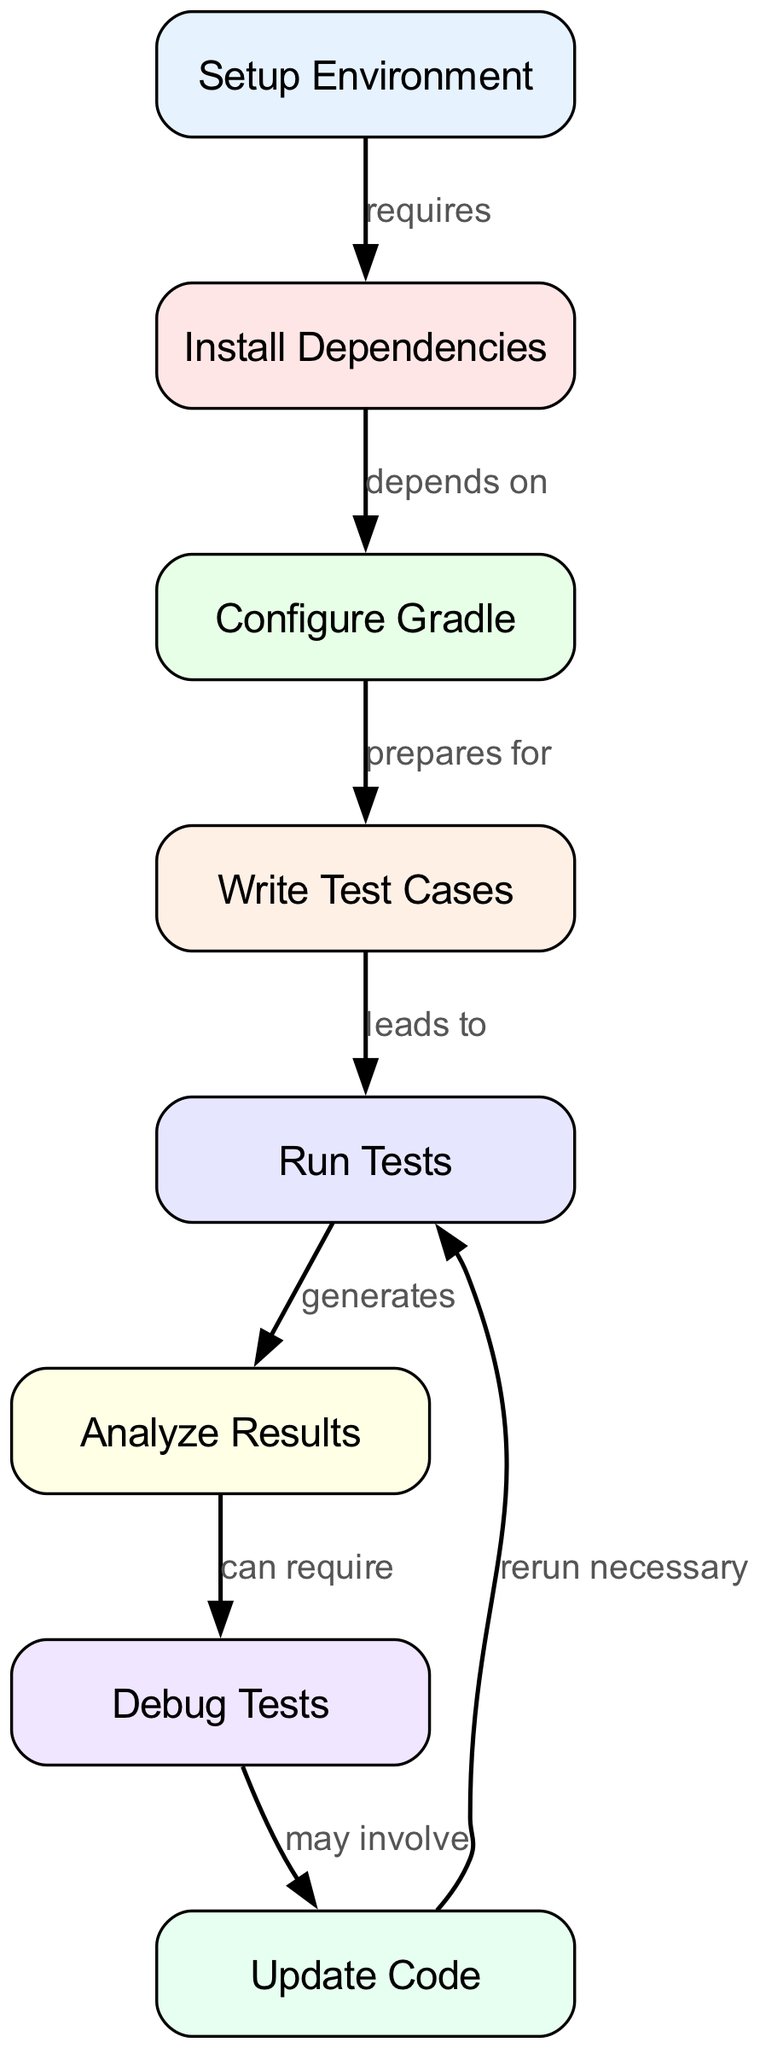What is the first step in the diagram? The first step, as indicated by the node at the top, is "Setup Environment".
Answer: Setup Environment How many nodes are there in the diagram? By counting each unique node listed in the diagram, we find that there are a total of eight nodes.
Answer: 8 What does "Setup Environment" require? The edge connecting "Setup Environment" to "Install Dependencies" indicates that it requires "Install Dependencies".
Answer: Install Dependencies What does "runTests" generate? The flow from "runTests" to "analyzeResults" shows that "runTests" generates "analyzeResults".
Answer: Analyze Results What may involve debugging? The arrow going from "debugTests" indicates that debugging may involve "Update Code".
Answer: Update Code How many edges connect "installDependencies" to other nodes? By examining the edges, we see that "installDependencies" connects to one other node, which is "configureGradle".
Answer: 1 What precedes "writeTestCases"? The flow in the diagram indicates that "configureGradle" prepares for "writeTestCases".
Answer: Configure Gradle What happens after analyzing results? The edge from "analyzeResults" to "debugTests" indicates that after analyzing results, debugging may be required.
Answer: Debug Tests Which step leads to running tests? The direction from "writeTestCases" to "runTests" indicates that "writeTestCases" leads to running tests.
Answer: Write Test Cases 